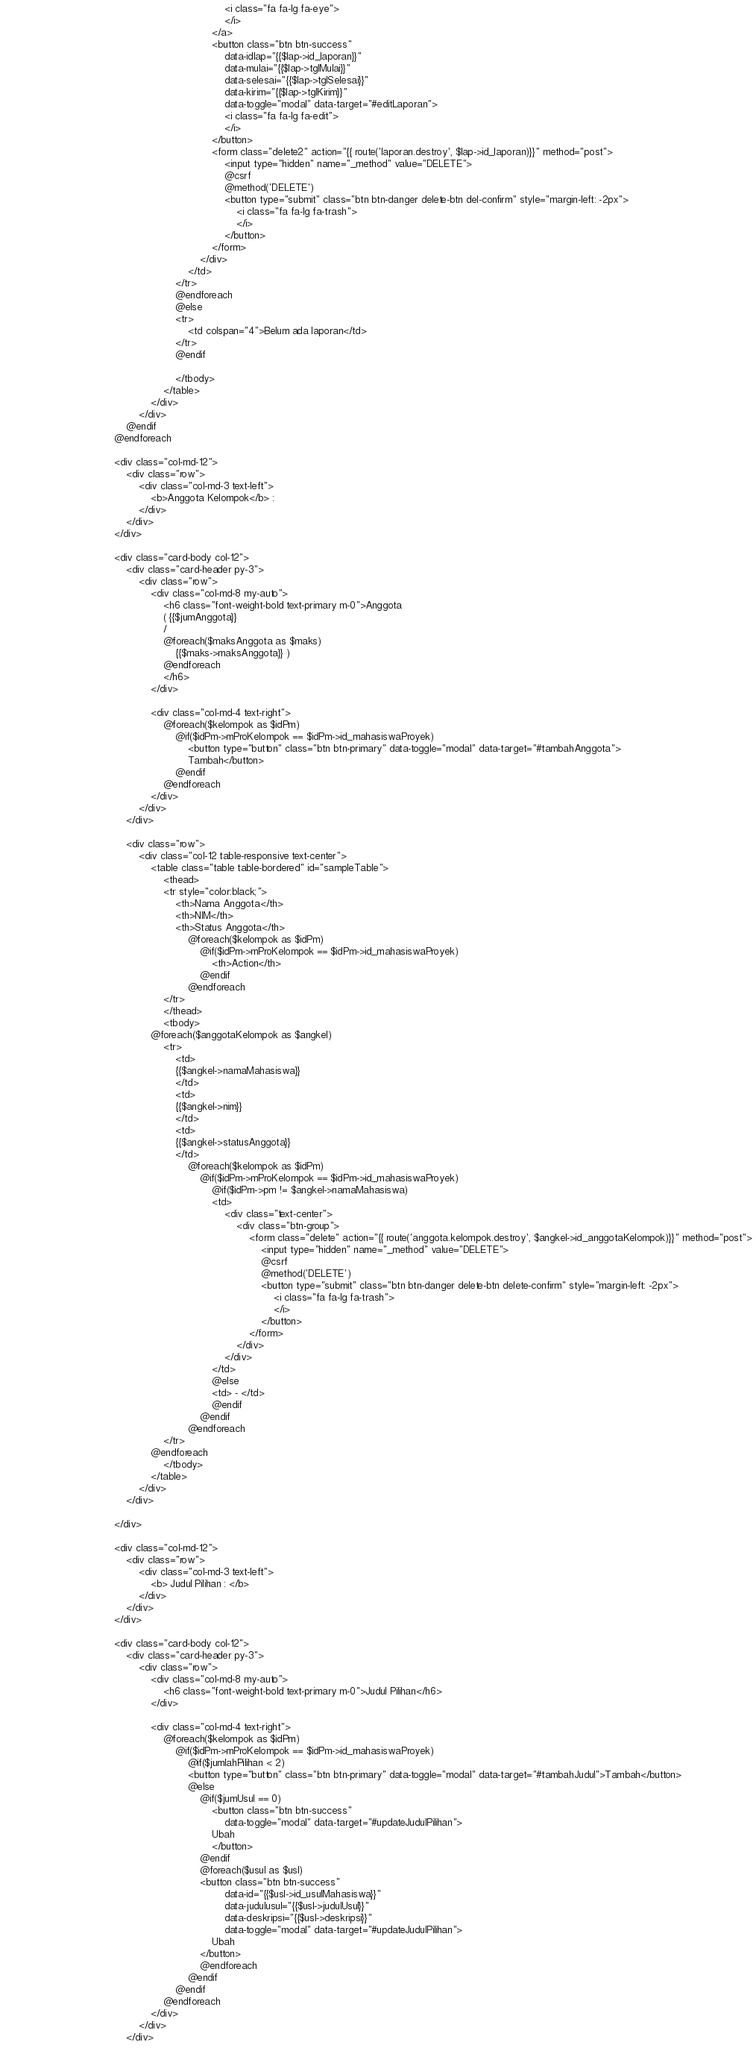Convert code to text. <code><loc_0><loc_0><loc_500><loc_500><_PHP_>                                                                        <i class="fa fa-lg fa-eye">
                                                                        </i>
                                                                    </a>
                                                                    <button class="btn btn-success"
                                                                        data-idlap="{{$lap->id_laporan}}"
                                                                        data-mulai="{{$lap->tglMulai}}"
                                                                        data-selesai="{{$lap->tglSelesai}}"
                                                                        data-kirim="{{$lap->tglKirim}}"
                                                                        data-toggle="modal" data-target="#editLaporan">
                                                                        <i class="fa fa-lg fa-edit">
                                                                        </i>
                                                                    </button>
                                                                    <form class="delete2" action="{{ route('laporan.destroy', $lap->id_laporan)}}" method="post">
                                                                        <input type="hidden" name="_method" value="DELETE">
                                                                        @csrf
                                                                        @method('DELETE')
                                                                        <button type="submit" class="btn btn-danger delete-btn del-confirm" style="margin-left: -2px">
                                                                            <i class="fa fa-lg fa-trash">
                                                                            </i>
                                                                        </button>
                                                                    </form>
                                                                </div>
                                                            </td>
                                                        </tr>
                                                        @endforeach
                                                        @else
                                                        <tr>
                                                            <td colspan="4">Belum ada laporan</td>                                                       
                                                        </tr>
                                                        @endif

                                                        </tbody>
                                                    </table>
                                                </div>
                                            </div>
                                        @endif
                                    @endforeach

                                    <div class="col-md-12">
                                        <div class="row">
                                            <div class="col-md-3 text-left">
                                                <b>Anggota Kelompok</b> :
                                            </div>
                                        </div>
                                    </div>

                                    <div class="card-body col-12">
                                        <div class="card-header py-3">
                                            <div class="row">
                                                <div class="col-md-8 my-auto">
                                                    <h6 class="font-weight-bold text-primary m-0">Anggota
                                                    ( {{$jumAnggota}} 
                                                    / 
                                                    @foreach($maksAnggota as $maks) 
                                                        {{$maks->maksAnggota}} )
                                                    @endforeach
                                                    </h6>
                                                </div>
                                               
                                                <div class="col-md-4 text-right">
                                                    @foreach($kelompok as $idPm)
                                                        @if($idPm->mProKelompok == $idPm->id_mahasiswaProyek)
                                                            <button type="button" class="btn btn-primary" data-toggle="modal" data-target="#tambahAnggota">
                                                            Tambah</button>
                                                        @endif
                                                    @endforeach   
                                                </div>
                                            </div>
                                        </div>

                                        <div class="row">
                                            <div class="col-12 table-responsive text-center">
                                                <table class="table table-bordered" id="sampleTable">
                                                    <thead>
                                                    <tr style="color:black;">
                                                        <th>Nama Anggota</th>
                                                        <th>NIM</th>
                                                        <th>Status Anggota</th>
                                                            @foreach($kelompok as $idPm)
                                                                @if($idPm->mProKelompok == $idPm->id_mahasiswaProyek)
                                                                    <th>Action</th>
                                                                @endif
                                                            @endforeach
                                                    </tr>
                                                    </thead>
                                                    <tbody>
                                                @foreach($anggotaKelompok as $angkel)
                                                    <tr>
                                                        <td>
                                                        {{$angkel->namaMahasiswa}}
                                                        </td>
                                                        <td>
                                                        {{$angkel->nim}}    
                                                        </td>
                                                        <td>
                                                        {{$angkel->statusAnggota}}    
                                                        </td>
                                                            @foreach($kelompok as $idPm)
                                                                @if($idPm->mProKelompok == $idPm->id_mahasiswaProyek)
                                                                    @if($idPm->pm != $angkel->namaMahasiswa)
                                                                    <td>
                                                                        <div class="text-center">
                                                                            <div class="btn-group">
                                                                                <form class="delete" action="{{ route('anggota.kelompok.destroy', $angkel->id_anggotaKelompok)}}" method="post">
                                                                                    <input type="hidden" name="_method" value="DELETE">
                                                                                    @csrf
                                                                                    @method('DELETE')
                                                                                    <button type="submit" class="btn btn-danger delete-btn delete-confirm" style="margin-left: -2px">
                                                                                        <i class="fa fa-lg fa-trash">
                                                                                        </i>
                                                                                    </button>
                                                                                </form>
                                                                            </div>
                                                                        </div>
                                                                    </td>
                                                                    @else
                                                                    <td> - </td>
                                                                    @endif
                                                                @endif
                                                            @endforeach
                                                    </tr>                                          
                                                @endforeach
                                                    </tbody>
                                                </table>
                                            </div>
                                        </div>

                                    </div>

                                    <div class="col-md-12">
                                        <div class="row">
                                            <div class="col-md-3 text-left">
                                                <b> Judul Pilihan : </b>
                                            </div>
                                        </div>
                                    </div>

                                    <div class="card-body col-12">
                                        <div class="card-header py-3">
                                            <div class="row">
                                                <div class="col-md-8 my-auto">
                                                    <h6 class="font-weight-bold text-primary m-0">Judul Pilihan</h6>
                                                </div>

                                                <div class="col-md-4 text-right">
                                                    @foreach($kelompok as $idPm)
                                                        @if($idPm->mProKelompok == $idPm->id_mahasiswaProyek)
                                                            @if($jumlahPilihan < 2)
                                                            <button type="button" class="btn btn-primary" data-toggle="modal" data-target="#tambahJudul">Tambah</button>
                                                            @else
                                                                @if($jumUsul == 0)
                                                                    <button class="btn btn-success"
                                                                        data-toggle="modal" data-target="#updateJudulPilihan">
                                                                    Ubah
                                                                    </button>
                                                                @endif
                                                                @foreach($usul as $usl)                                                           
                                                                <button class="btn btn-success"
                                                                        data-id="{{$usl->id_usulMahasiswa}}"
                                                                        data-judulusul="{{$usl->judulUsul}}"
                                                                        data-deskripsi="{{$usl->deskripsi}}"
                                                                        data-toggle="modal" data-target="#updateJudulPilihan">
                                                                    Ubah
                                                                </button>
                                                                @endforeach
                                                            @endif
                                                        @endif
                                                    @endforeach
                                                </div>
                                            </div>
                                        </div>
</code> 